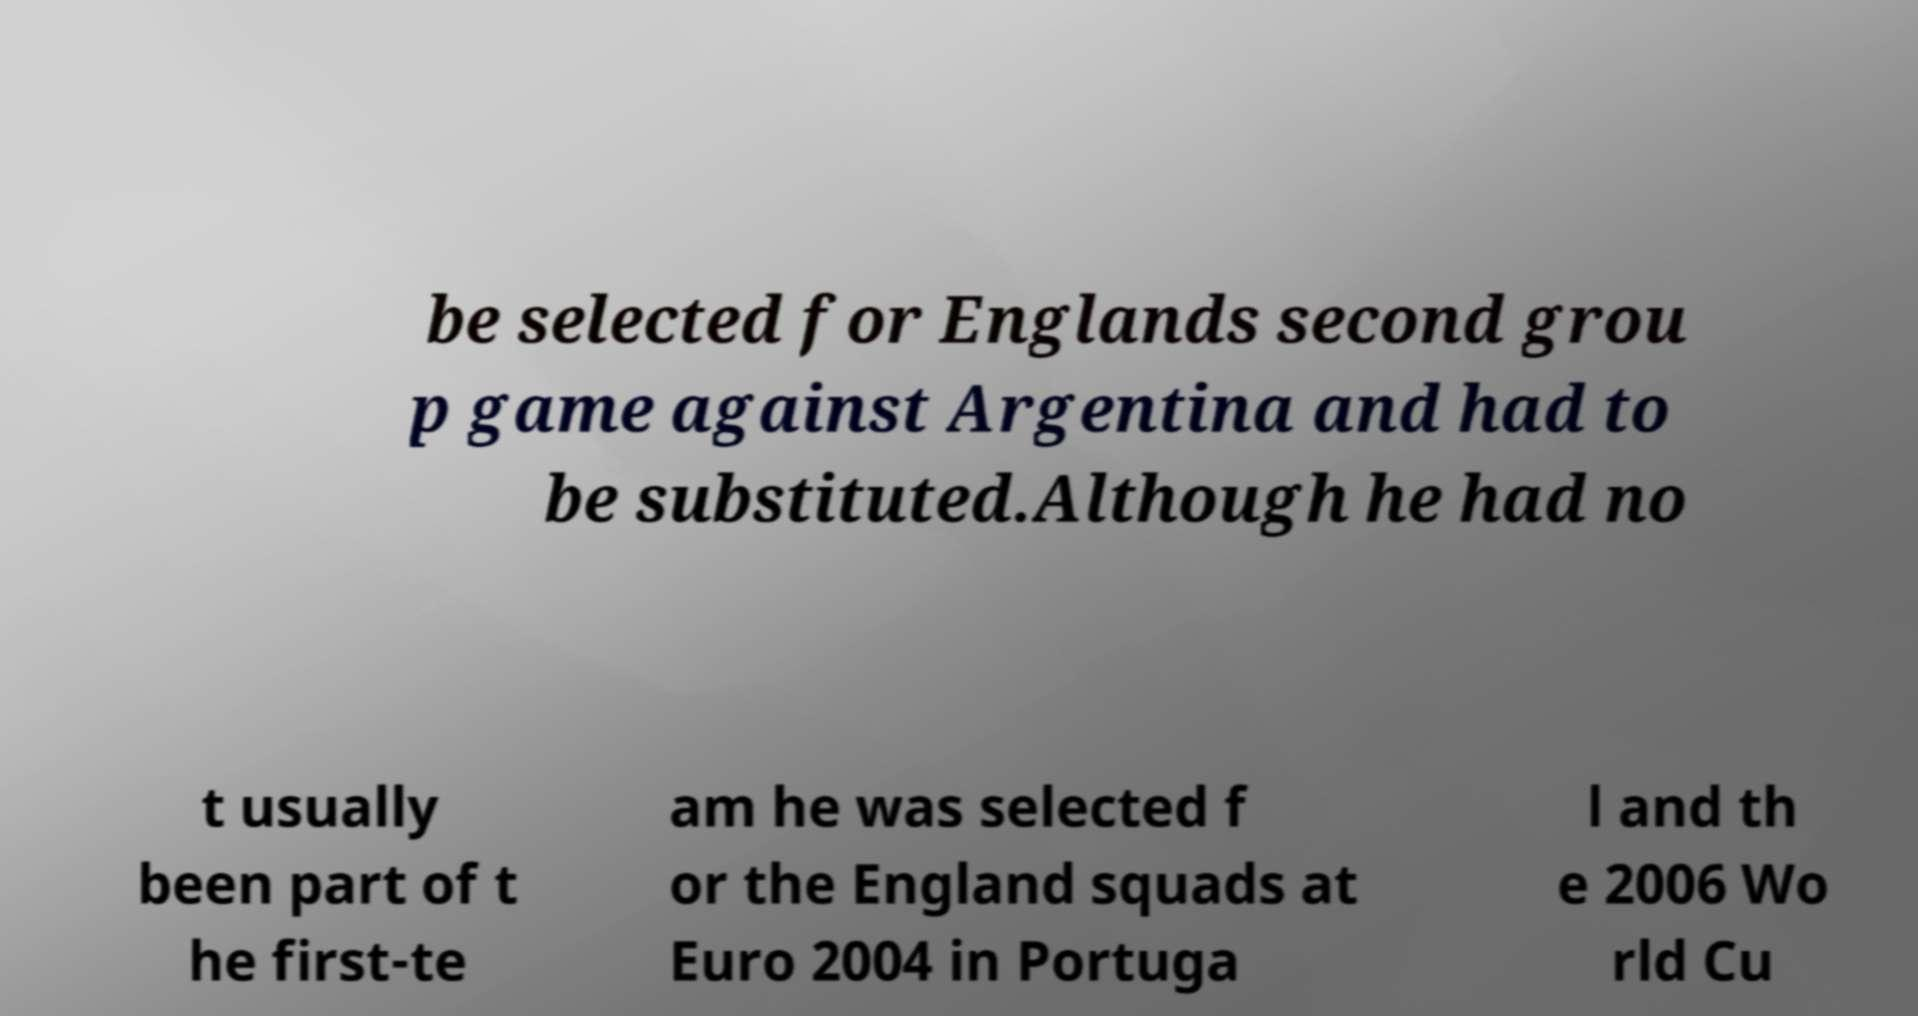Can you read and provide the text displayed in the image?This photo seems to have some interesting text. Can you extract and type it out for me? be selected for Englands second grou p game against Argentina and had to be substituted.Although he had no t usually been part of t he first-te am he was selected f or the England squads at Euro 2004 in Portuga l and th e 2006 Wo rld Cu 